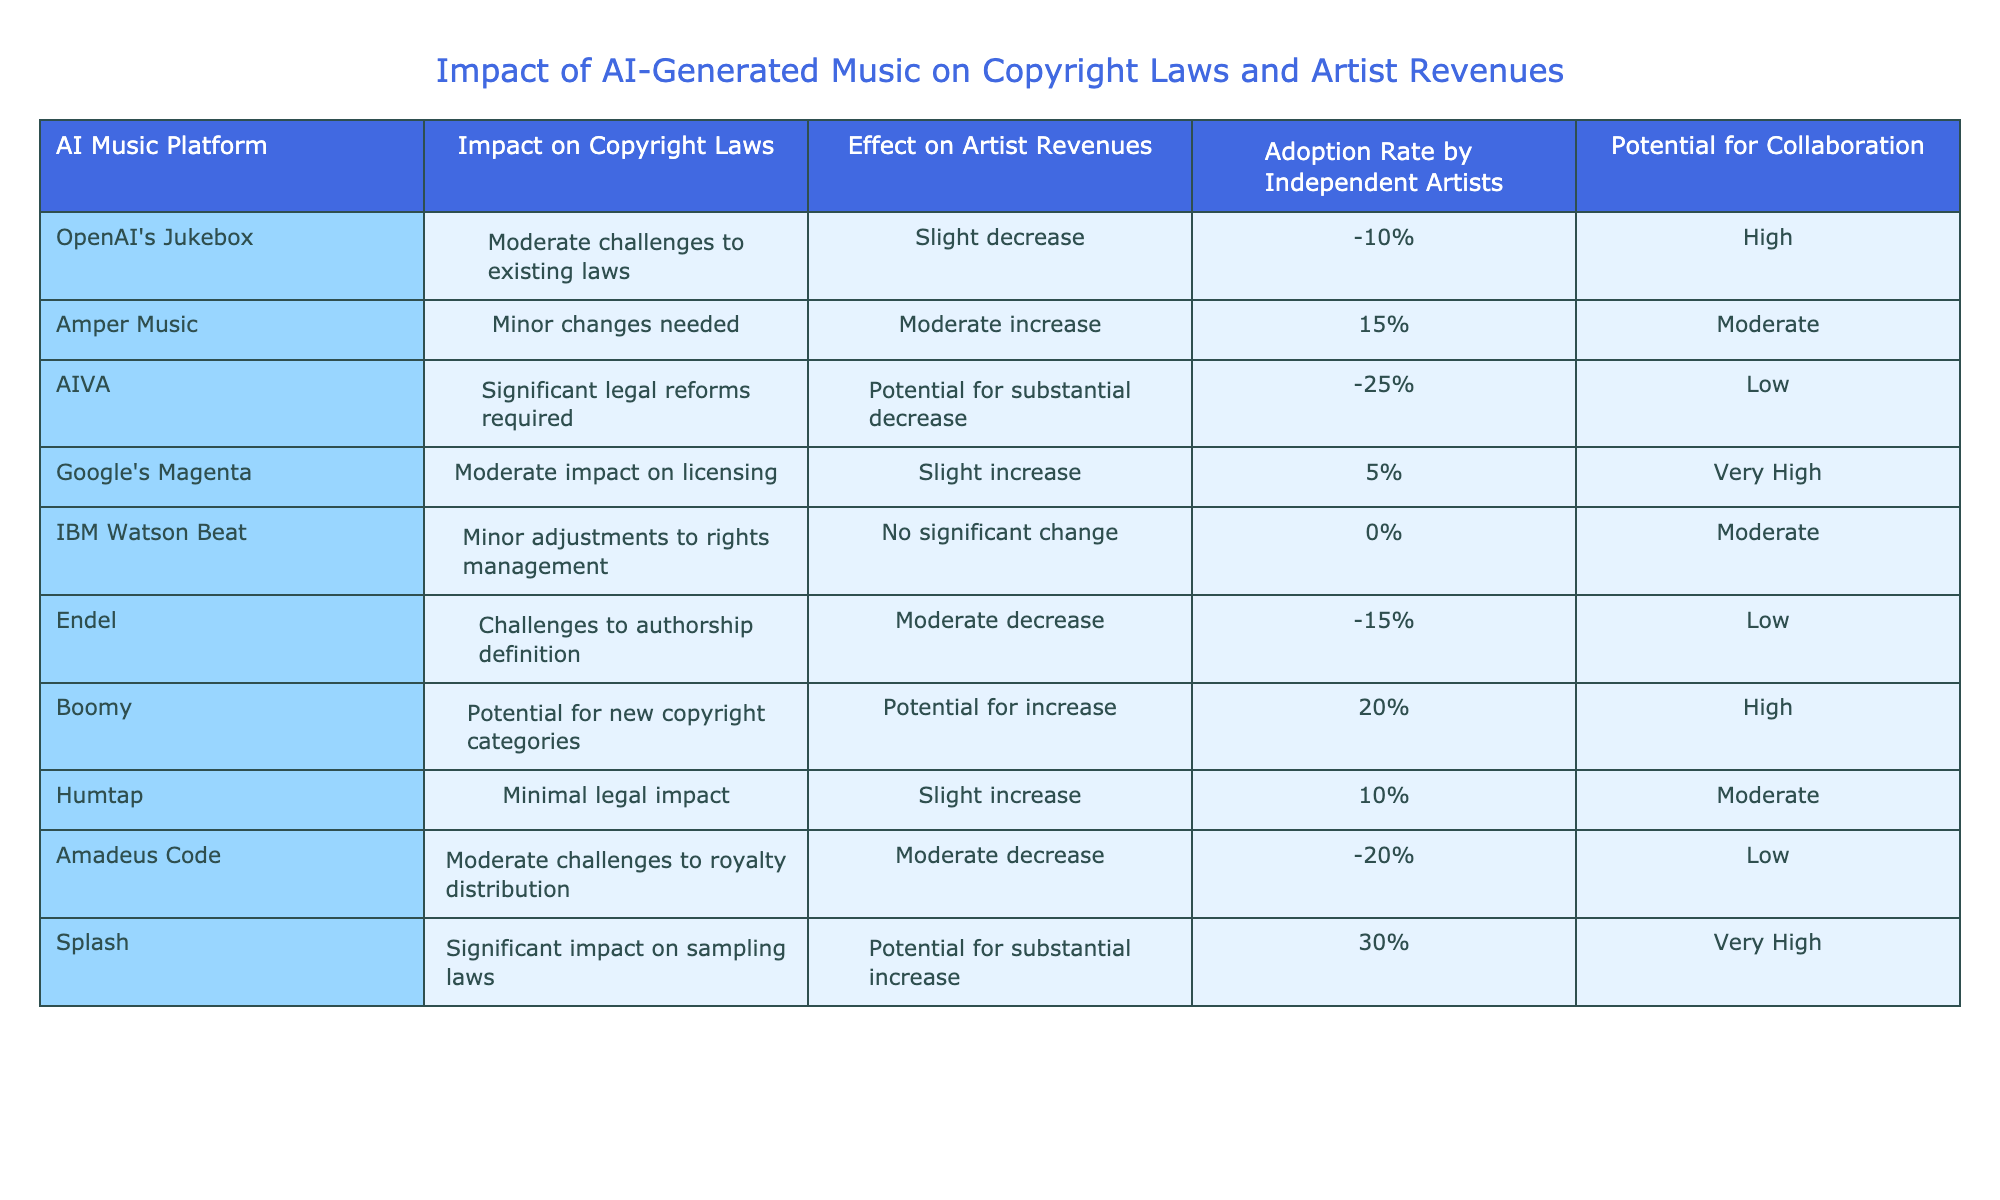What are the potential impacts of AI-generated music on copyright laws according to the table? Potential impacts range from minor changes to significant legal reforms required. Specifically, platforms like Amper Music indicate minor changes, while AIVA suggests significant reforms.
Answer: Moderate challenges to existing laws Which AI music platform has a moderate increase in artist revenues? According to the table, Amper Music shows a moderate increase in artist revenues of 15%.
Answer: Amper Music What is the adoption rate by independent artists for AIVA? The table states that AIVA has a low adoption rate by independent artists.
Answer: Low Which platform indicates a challenge to authorship definition? Endel is listed in the table as having challenges to authorship definition.
Answer: Endel Is there any platform that indicates a potential for substantial increase in artist revenues? Yes, both Splash and Boomy indicate a potential for substantial increase in artist revenues.
Answer: Yes What is the average effect on artist revenues for platforms that indicate a decrease? The platforms indicating a decrease are AIVA (-25%), Amadeus Code (-20%), and Endel (-15%). Summing these gives -60%, and averaging over 3 platforms gives -60% / 3 = -20%.
Answer: -20% How many platforms show a high potential for collaboration? Two platforms, OpenAI's Jukebox and Splash, are noted to have a high potential for collaboration.
Answer: 2 Which platform reports no significant change in artist revenues? According to the data, IBM Watson Beat reports no significant change in artist revenues at 0%.
Answer: IBM Watson Beat What is the relationship between the impact on copyright laws and the effect on artist revenues for Boomy? Boomy indicates potential for new copyright categories, which could lead to an increase in artist revenues. This suggests a positive relationship.
Answer: Positive relationship Which AI music platform shows significant impact on sampling laws? The table states that Splash has a significant impact on sampling laws.
Answer: Splash 